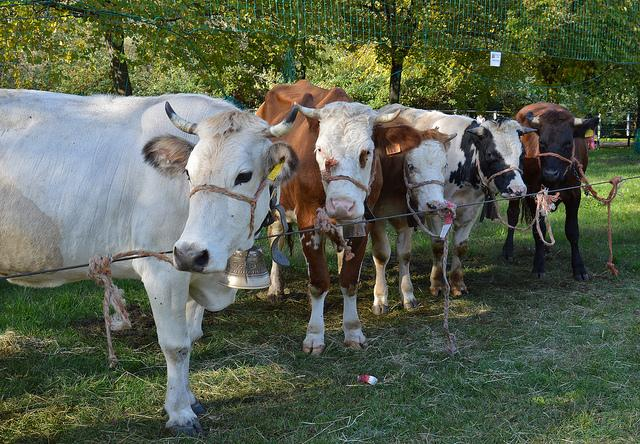What is the most common breed of milk cow? Please explain your reasoning. holstein. The holstein cow is the most common cow used at a dairy farm 